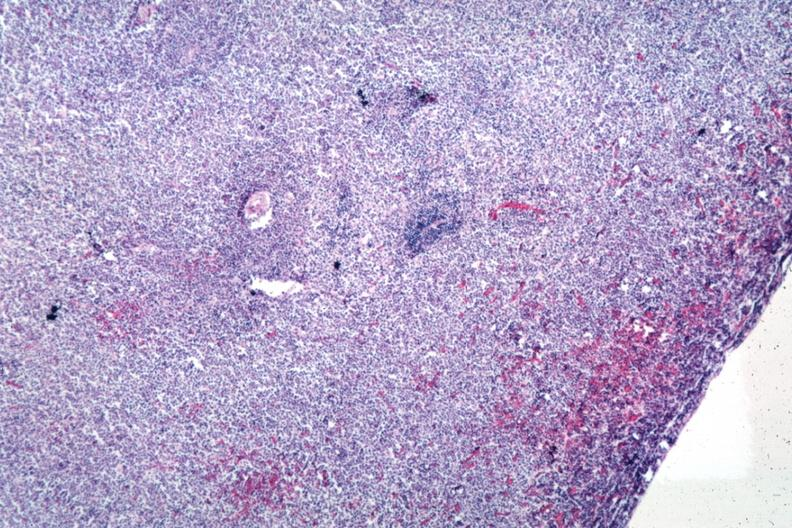s lymphoblastic lymphoma present?
Answer the question using a single word or phrase. Yes 